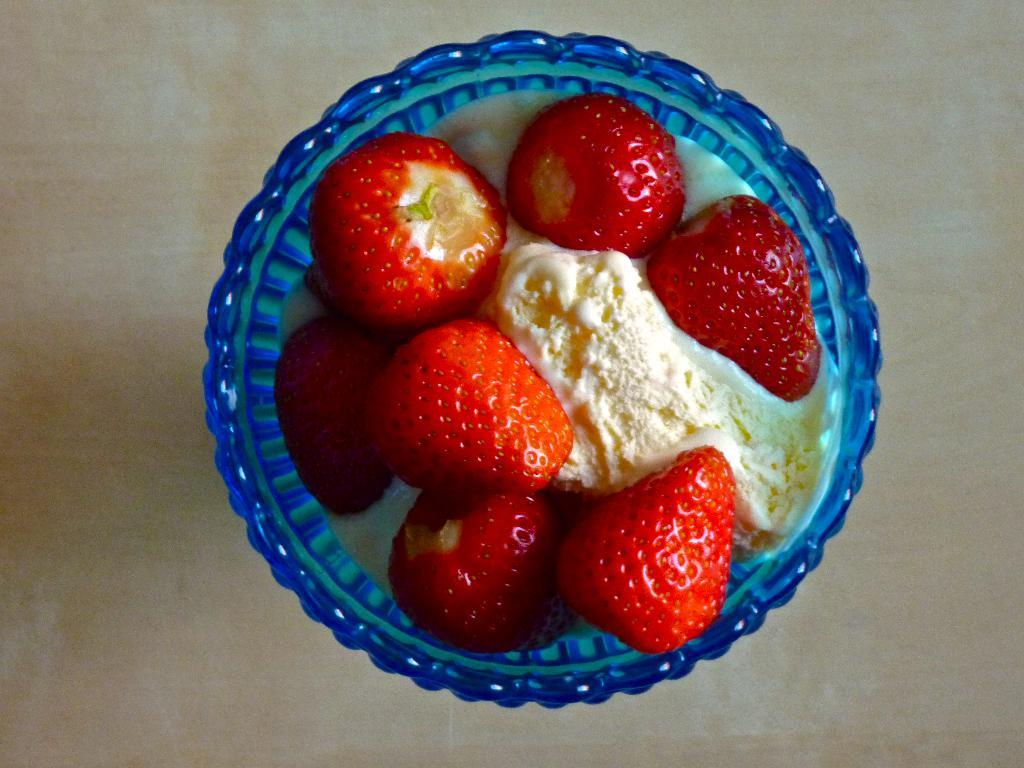What type of fruit is present in the image? There are cherries in the image. What color are the cherries? The cherries are red. What is the main dessert item in the image? There is ice cream in the image. What color is the ice cream? The ice cream is cream-colored. What is the ice cream contained in? The ice cream is in a bowl. What color is the bowl? The bowl is blue. What is the color of the surface the bowl is placed on? The bowl is on a cream-colored surface. What caption is written on the ice cream in the image? There is no caption written on the ice cream in the image. What line can be seen connecting the cherries to the ice cream? There is no line connecting the cherries to the ice cream in the image. 